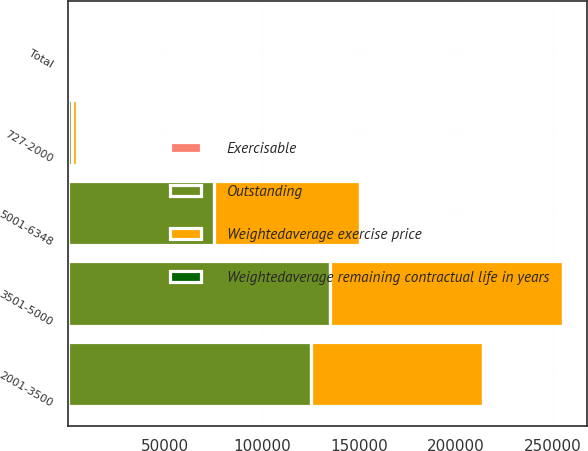<chart> <loc_0><loc_0><loc_500><loc_500><stacked_bar_chart><ecel><fcel>727-2000<fcel>2001-3500<fcel>3501-5000<fcel>5001-6348<fcel>Total<nl><fcel>Outstanding<fcel>2504<fcel>125422<fcel>135263<fcel>75386<fcel>45.655<nl><fcel>Weightedaverage remaining contractual life in years<fcel>19.12<fcel>28.02<fcel>40.04<fcel>51.27<fcel>37.93<nl><fcel>Exercisable<fcel>0.8<fcel>5.8<fcel>4.9<fcel>4.8<fcel>5.2<nl><fcel>Weightedaverage exercise price<fcel>2503<fcel>88418<fcel>119710<fcel>75386<fcel>45.655<nl></chart> 